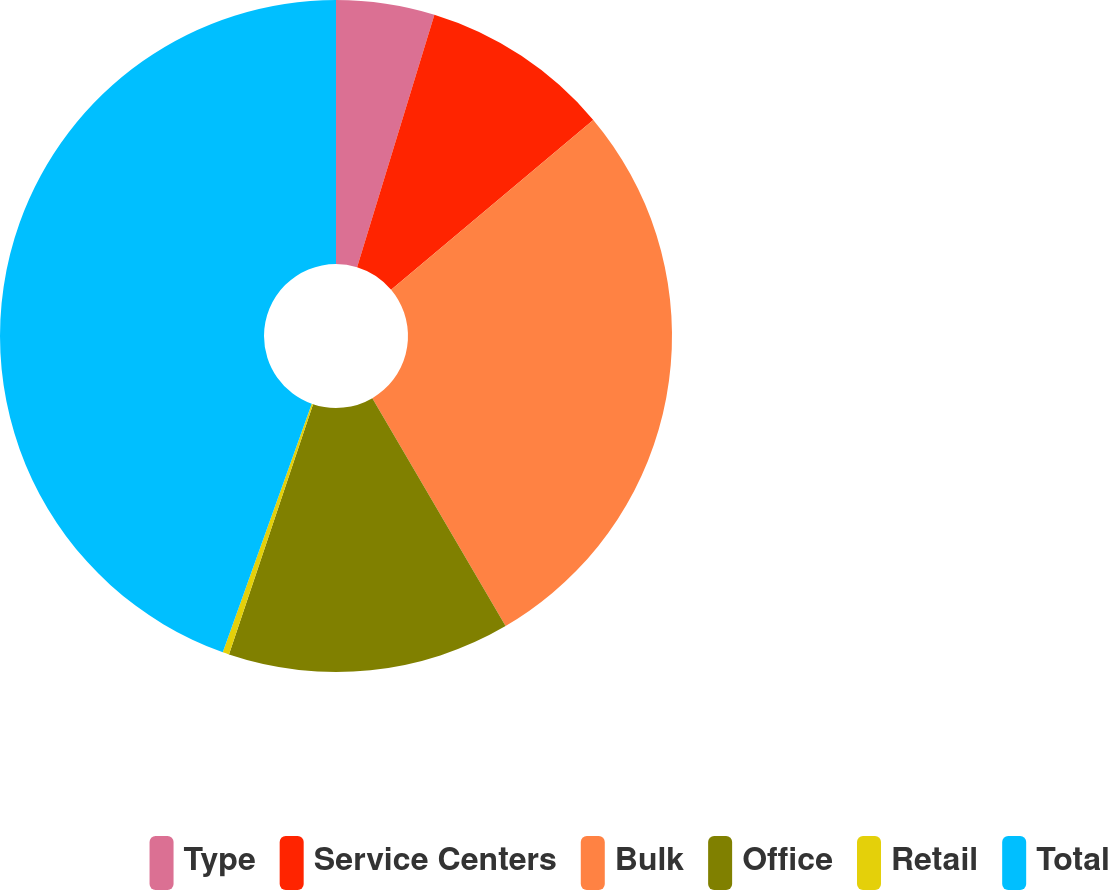Convert chart to OTSL. <chart><loc_0><loc_0><loc_500><loc_500><pie_chart><fcel>Type<fcel>Service Centers<fcel>Bulk<fcel>Office<fcel>Retail<fcel>Total<nl><fcel>4.73%<fcel>9.15%<fcel>27.7%<fcel>13.58%<fcel>0.31%<fcel>44.53%<nl></chart> 